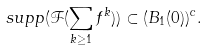Convert formula to latex. <formula><loc_0><loc_0><loc_500><loc_500>s u p p ( \mathcal { F } ( \sum _ { k \geq 1 } f ^ { k } ) ) \subset ( B _ { 1 } ( 0 ) ) ^ { c } .</formula> 